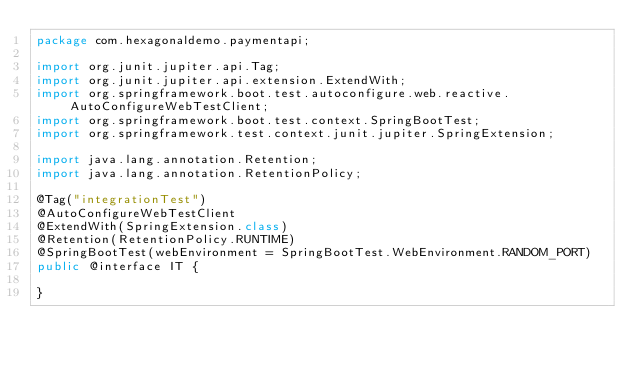<code> <loc_0><loc_0><loc_500><loc_500><_Java_>package com.hexagonaldemo.paymentapi;

import org.junit.jupiter.api.Tag;
import org.junit.jupiter.api.extension.ExtendWith;
import org.springframework.boot.test.autoconfigure.web.reactive.AutoConfigureWebTestClient;
import org.springframework.boot.test.context.SpringBootTest;
import org.springframework.test.context.junit.jupiter.SpringExtension;

import java.lang.annotation.Retention;
import java.lang.annotation.RetentionPolicy;

@Tag("integrationTest")
@AutoConfigureWebTestClient
@ExtendWith(SpringExtension.class)
@Retention(RetentionPolicy.RUNTIME)
@SpringBootTest(webEnvironment = SpringBootTest.WebEnvironment.RANDOM_PORT)
public @interface IT {

}
</code> 